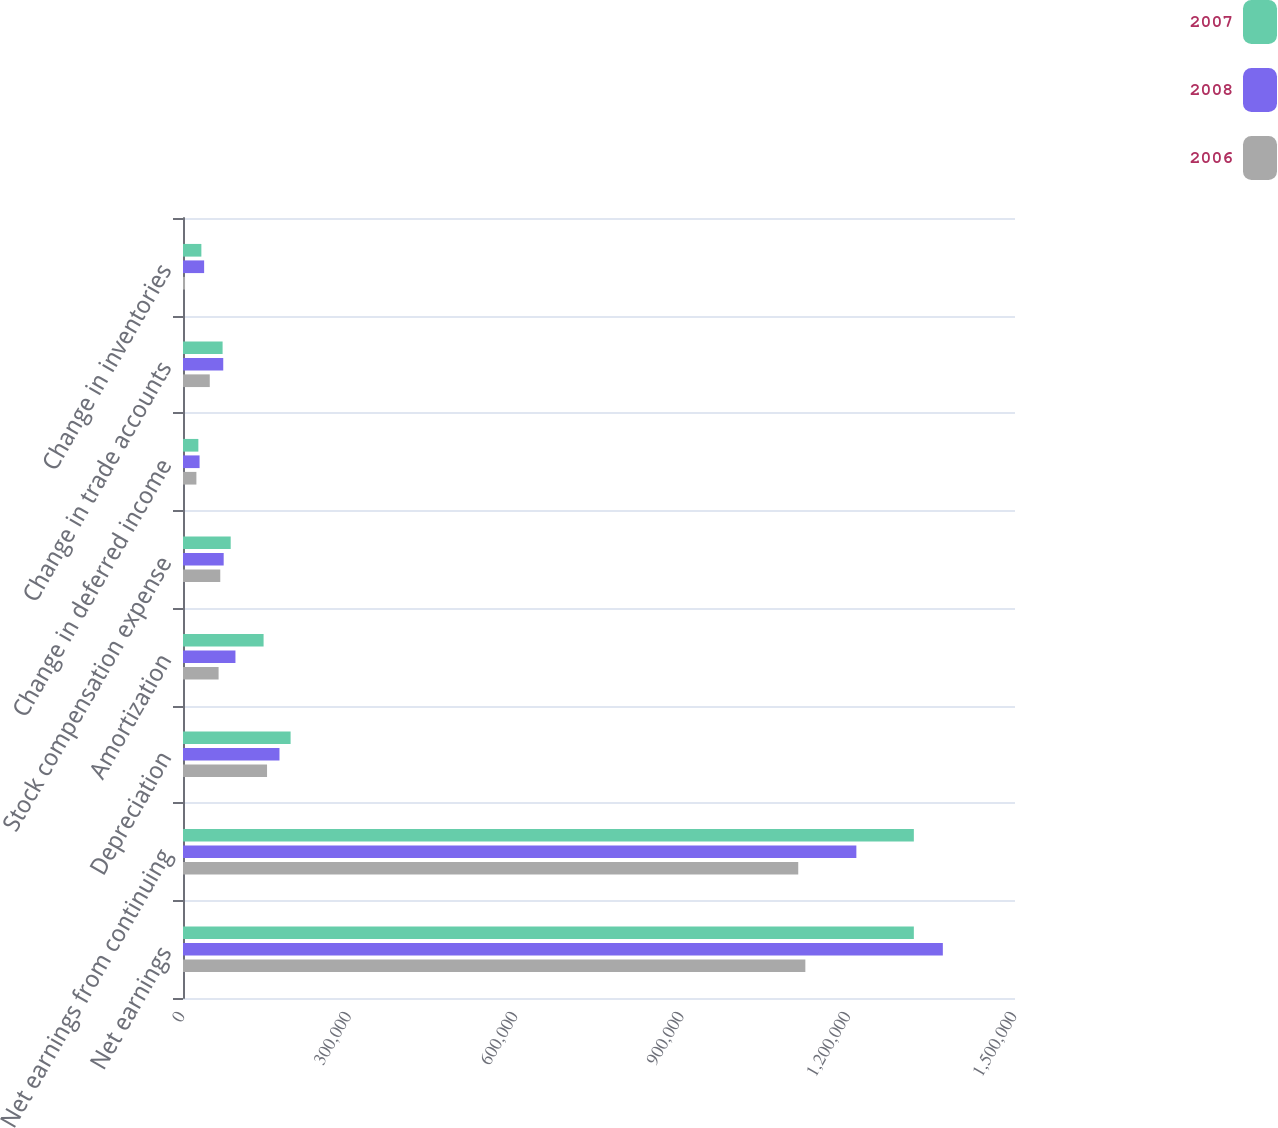Convert chart to OTSL. <chart><loc_0><loc_0><loc_500><loc_500><stacked_bar_chart><ecel><fcel>Net earnings<fcel>Net earnings from continuing<fcel>Depreciation<fcel>Amortization<fcel>Stock compensation expense<fcel>Change in deferred income<fcel>Change in trade accounts<fcel>Change in inventories<nl><fcel>2007<fcel>1.31763e+06<fcel>1.31763e+06<fcel>193997<fcel>145290<fcel>86000<fcel>27691<fcel>71403<fcel>33119<nl><fcel>2008<fcel>1.3699e+06<fcel>1.214e+06<fcel>173942<fcel>94550<fcel>73347<fcel>29870<fcel>72555<fcel>38094<nl><fcel>2006<fcel>1.12203e+06<fcel>1.10921e+06<fcel>151524<fcel>64173<fcel>67191<fcel>24154<fcel>48255<fcel>3683<nl></chart> 